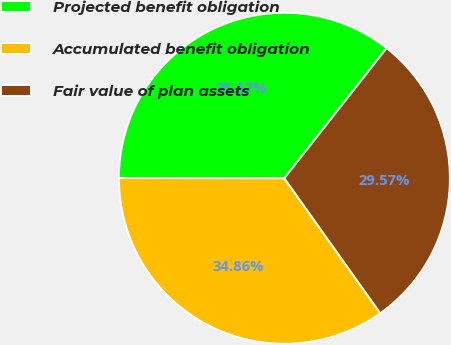Convert chart to OTSL. <chart><loc_0><loc_0><loc_500><loc_500><pie_chart><fcel>Projected benefit obligation<fcel>Accumulated benefit obligation<fcel>Fair value of plan assets<nl><fcel>35.57%<fcel>34.86%<fcel>29.57%<nl></chart> 